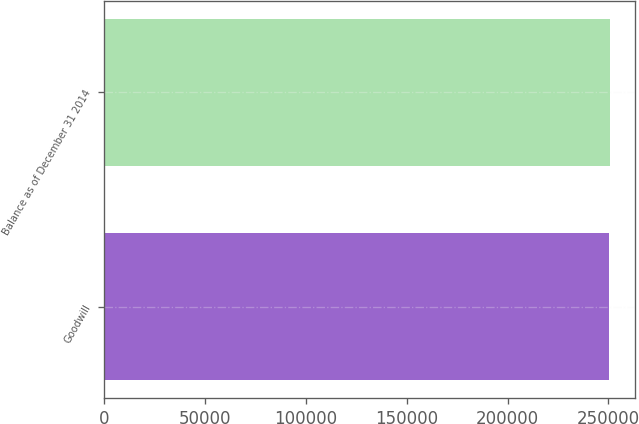Convert chart. <chart><loc_0><loc_0><loc_500><loc_500><bar_chart><fcel>Goodwill<fcel>Balance as of December 31 2014<nl><fcel>250506<fcel>250912<nl></chart> 